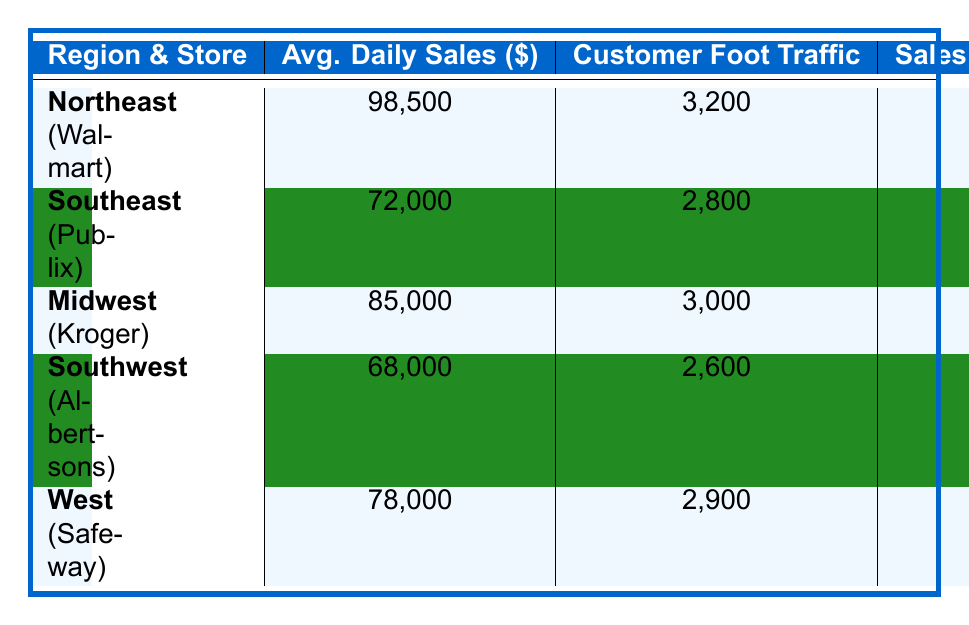What is the average daily sales for the store located in the Northeast? The table shows that Walmart, located in the Northeast, has an average daily sales of $98,500.
Answer: $98,500 Which store has the highest customer foot traffic? In the table, Walmart has the highest customer foot traffic with 3,200 customers.
Answer: Walmart What is the sales per square foot for Publix? According to the table, Publix has sales per square foot of $380.
Answer: $380 Which region has the lowest inventory turnover rate? By examining the table, we find that Albertsons in the Southwest has the lowest inventory turnover rate at 12.2.
Answer: Southwest How does Walmart's employee productivity compare to that of Kroger? Walmart's employee productivity is $85 per hour, while Kroger's is $80 per hour. Therefore, Walmart's employee productivity is higher by $5.
Answer: Higher by $5 What is the total average daily sales of the stores in the Southeast and Southwest regions combined? The average daily sales for Publix in the Southeast is $72,000, and for Albertsons in the Southwest, it is $68,000. Combining these gives $72,000 + $68,000 = $140,000.
Answer: $140,000 Is it true that Safeway has more customer foot traffic than Albertsons? According to the table, Safeway has 2,900 customers while Albertsons has 2,600 customers, which means Safeway does have more foot traffic than Albertsons.
Answer: True What is the average employee productivity across all stores? The average employee productivity can be calculated by adding all the values: (85 + 78 + 80 + 75 + 82) = 400. Divide by the number of stores (5) to find the average: 400 / 5 = 80.
Answer: 80 If we compare the inventory turnover rates, which store has the best performance? Analyzing the inventory turnover rates, Walmart has the highest rate at 14.2, indicating the best performance among the stores listed.
Answer: Walmart What is the difference in average daily sales between the store in the Midwest and the one in the Southeast? The average daily sales for Kroger in the Midwest is $85,000 and for Publix in the Southeast is $72,000. The difference is $85,000 - $72,000 = $13,000.
Answer: $13,000 